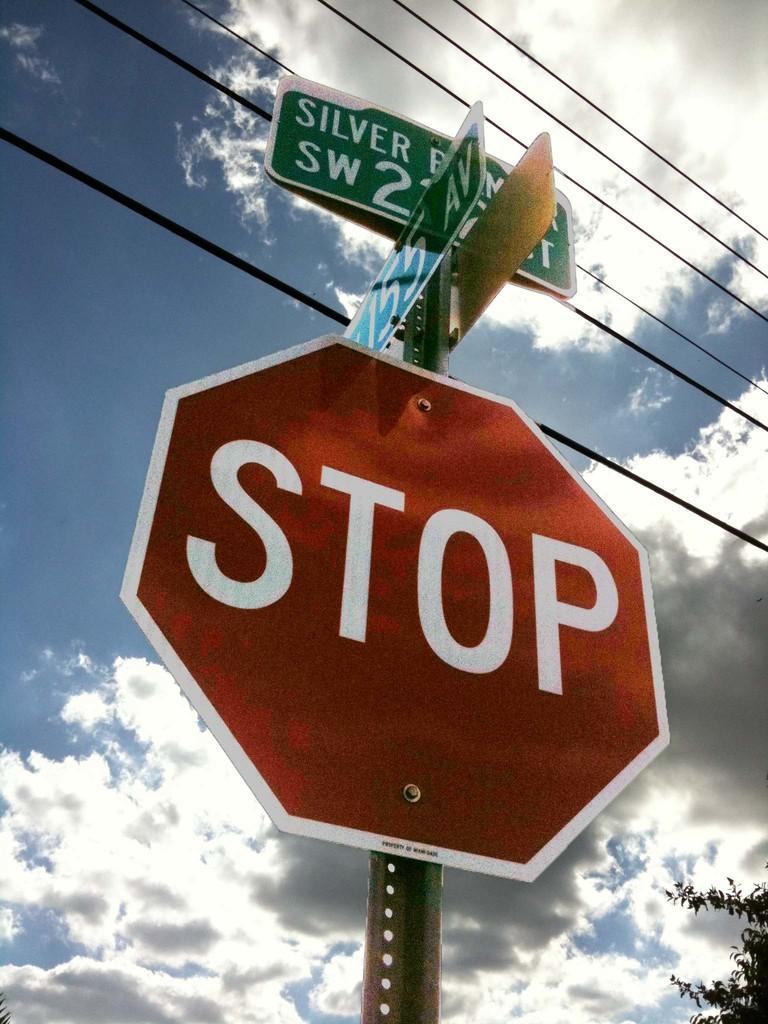Is that a stop sign?
Your answer should be very brief. Yes. What direction is the street sign?
Make the answer very short. Sw. 